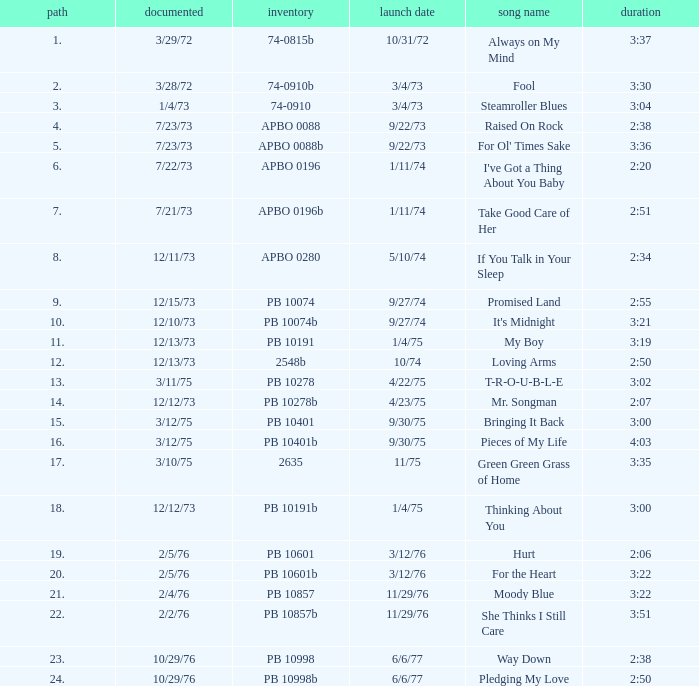Tell me the recorded for time of 2:50 and released date of 6/6/77 with track more than 20 10/29/76. 